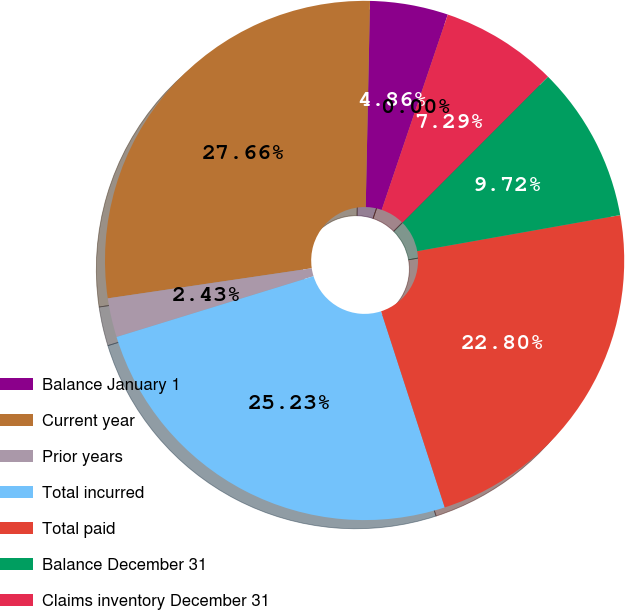Convert chart. <chart><loc_0><loc_0><loc_500><loc_500><pie_chart><fcel>Balance January 1<fcel>Current year<fcel>Prior years<fcel>Total incurred<fcel>Total paid<fcel>Balance December 31<fcel>Claims inventory December 31<fcel>Days in claims payable (a)<nl><fcel>4.86%<fcel>27.66%<fcel>2.43%<fcel>25.23%<fcel>22.8%<fcel>9.72%<fcel>7.29%<fcel>0.0%<nl></chart> 